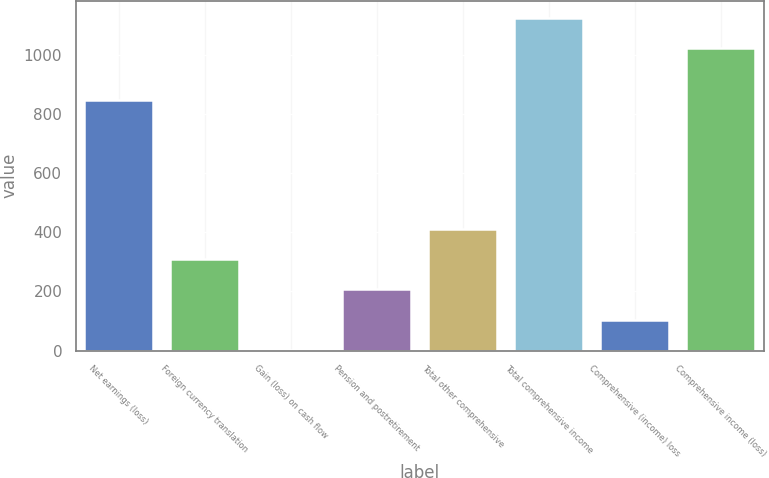<chart> <loc_0><loc_0><loc_500><loc_500><bar_chart><fcel>Net earnings (loss)<fcel>Foreign currency translation<fcel>Gain (loss) on cash flow<fcel>Pension and postretirement<fcel>Total other comprehensive<fcel>Total comprehensive income<fcel>Comprehensive (income) loss<fcel>Comprehensive income (loss)<nl><fcel>849<fcel>309.7<fcel>1<fcel>206.8<fcel>412.6<fcel>1126.9<fcel>103.9<fcel>1024<nl></chart> 